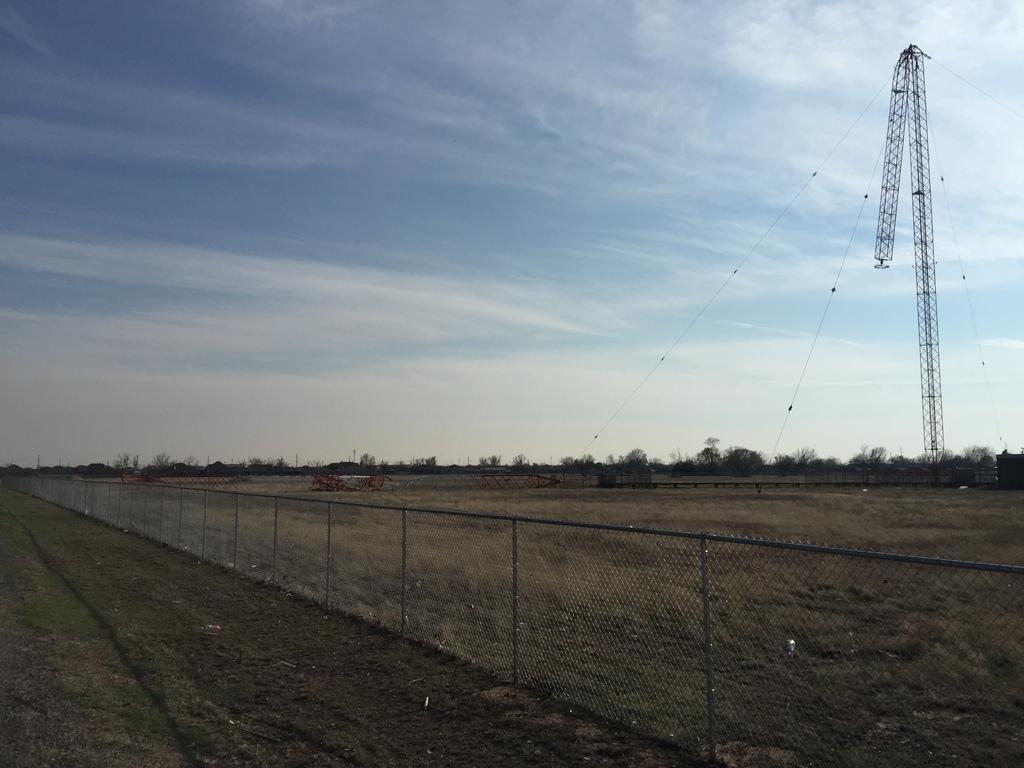Could you give a brief overview of what you see in this image? This image is taken outdoors. At the top of the image there is the sky with clouds. At the bottom of the image there is a ground with grass on it. In the background there are many trees and plants. On the right side of the image there is a tower and there are few wires. In the middle of the image there is a mesh. 